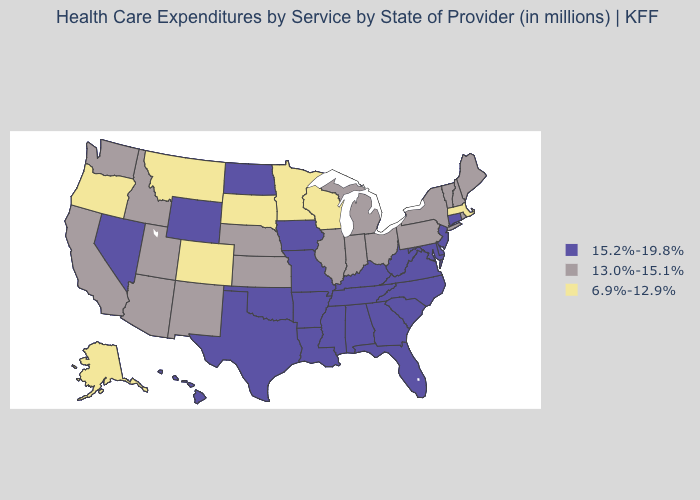Name the states that have a value in the range 15.2%-19.8%?
Concise answer only. Alabama, Arkansas, Connecticut, Delaware, Florida, Georgia, Hawaii, Iowa, Kentucky, Louisiana, Maryland, Mississippi, Missouri, Nevada, New Jersey, North Carolina, North Dakota, Oklahoma, South Carolina, Tennessee, Texas, Virginia, West Virginia, Wyoming. What is the highest value in states that border Massachusetts?
Answer briefly. 15.2%-19.8%. What is the value of Kansas?
Answer briefly. 13.0%-15.1%. Among the states that border South Carolina , which have the lowest value?
Answer briefly. Georgia, North Carolina. Does Indiana have a lower value than Nebraska?
Concise answer only. No. What is the value of Illinois?
Concise answer only. 13.0%-15.1%. Does the map have missing data?
Quick response, please. No. What is the value of Maine?
Quick response, please. 13.0%-15.1%. Name the states that have a value in the range 6.9%-12.9%?
Write a very short answer. Alaska, Colorado, Massachusetts, Minnesota, Montana, Oregon, South Dakota, Wisconsin. Among the states that border Utah , does Idaho have the highest value?
Short answer required. No. Is the legend a continuous bar?
Give a very brief answer. No. What is the value of Tennessee?
Quick response, please. 15.2%-19.8%. Name the states that have a value in the range 6.9%-12.9%?
Give a very brief answer. Alaska, Colorado, Massachusetts, Minnesota, Montana, Oregon, South Dakota, Wisconsin. 